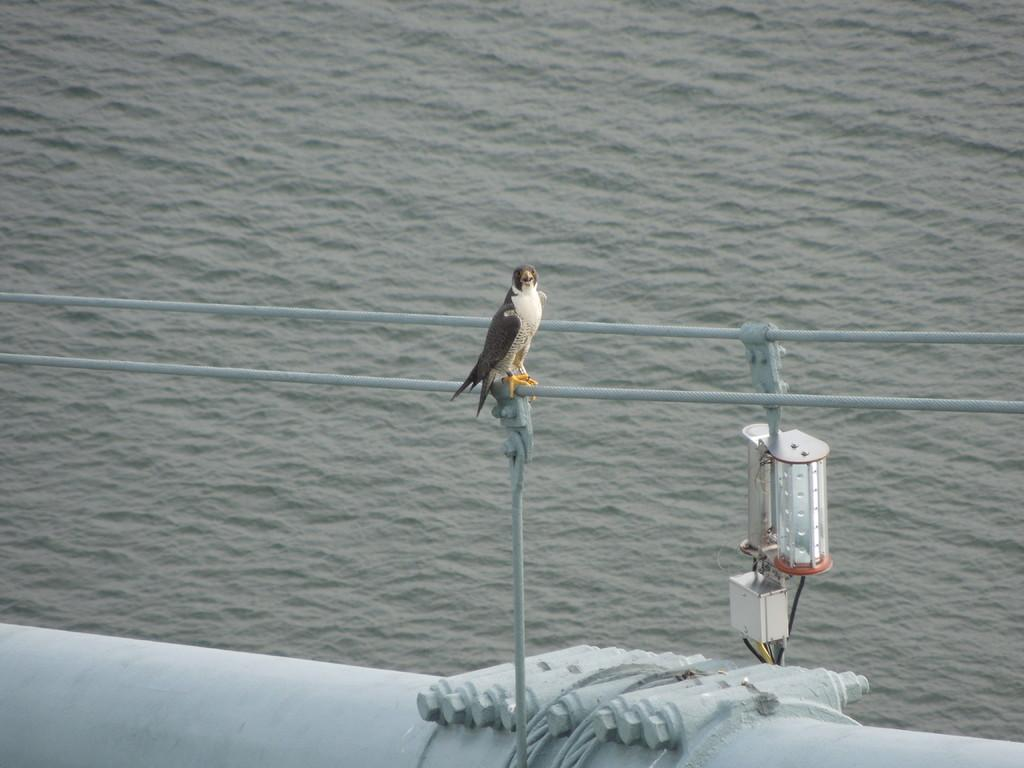What type of animal can be seen in the image? There is a bird in the image. What is the bird standing on? The bird is standing on a rod. What is attached to the rod? There is a light on the rod. What is at the bottom of the rod? There is a metal pipe at the bottom of the rod. What can be seen in the background of the image? Water is visible in the background of the image. How many women are present in the image? There are no women present in the image; it features a bird standing on a rod. What type of ear is visible in the image? There are no ears visible in the image; it features a bird standing on a rod with a light and metal pipe. 